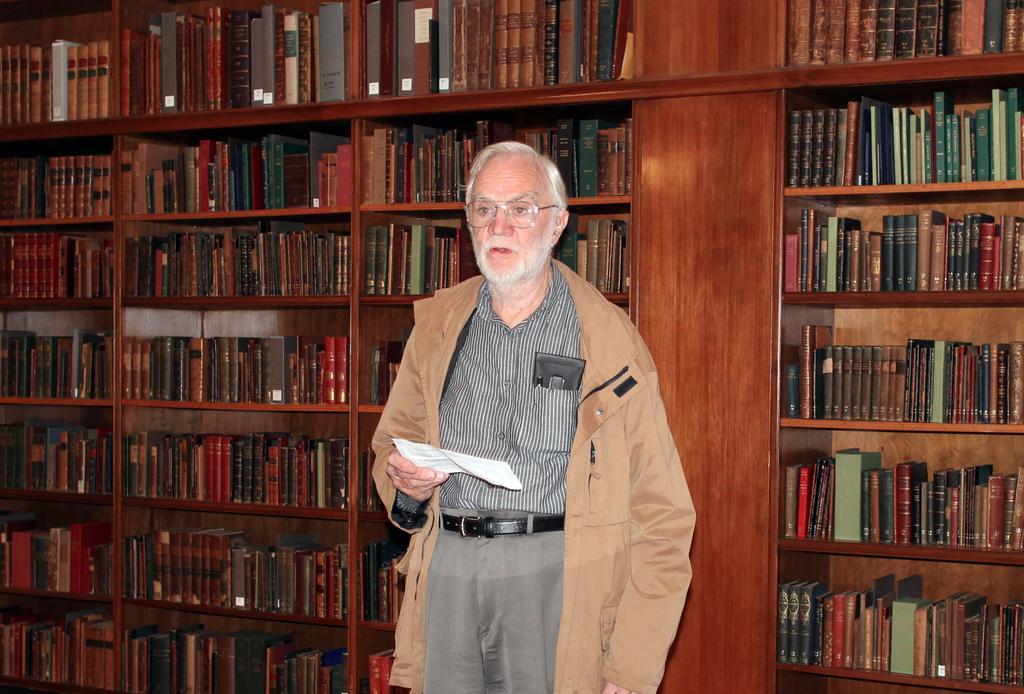Can you describe this image briefly? Here in the middle we can see an old man, wearing a jacket on him standing on the floor over there and he is holding a paper in his hand and he is also wearing spectacles on him and behind him we can see shelves present, which are covered with books all over there. 